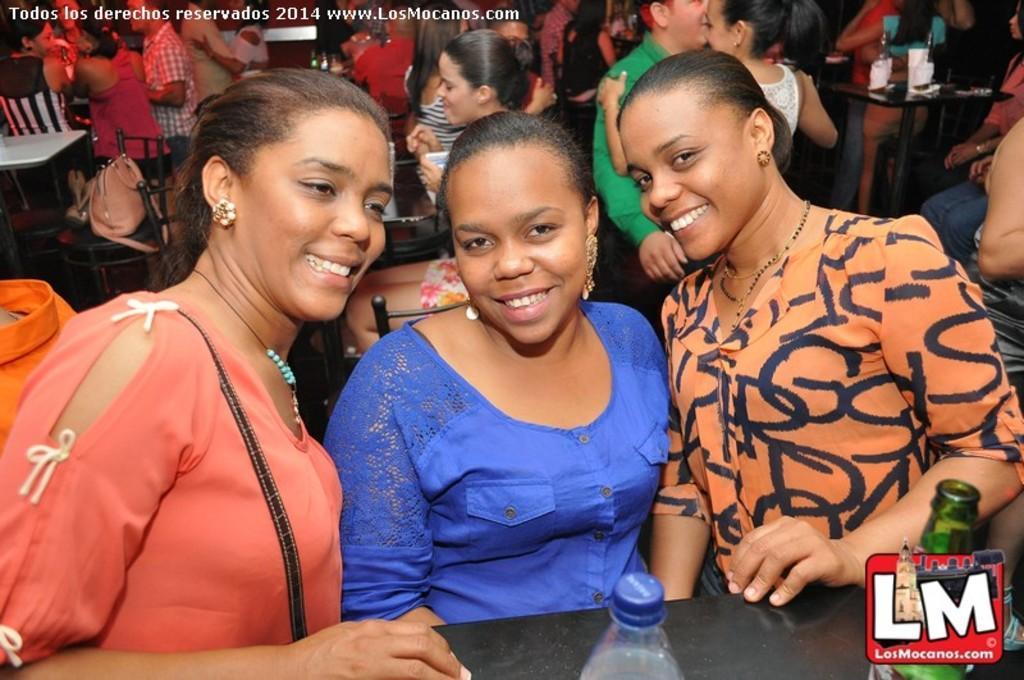Describe this image in one or two sentences. In this image we can see some people, a few of them are sitting and a few of them are standing at the back, there are a few tables and chairs, there are bottle on the table and a handbag on the chair. 